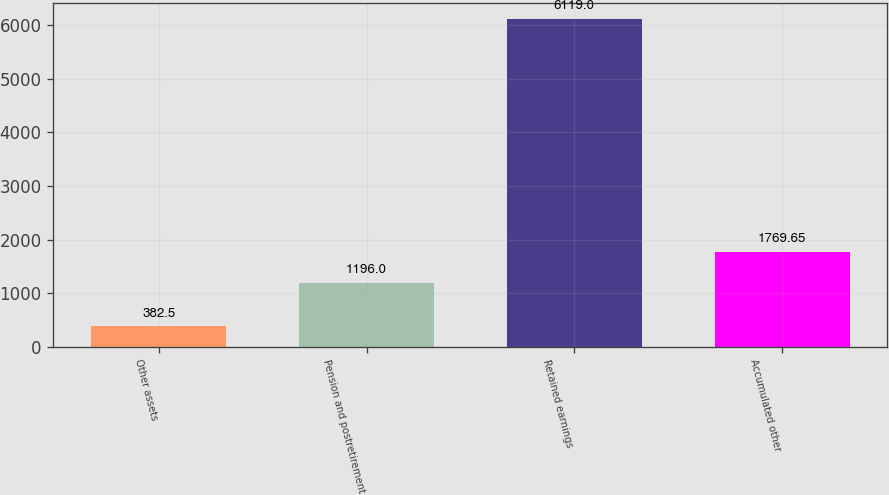Convert chart to OTSL. <chart><loc_0><loc_0><loc_500><loc_500><bar_chart><fcel>Other assets<fcel>Pension and postretirement<fcel>Retained earnings<fcel>Accumulated other<nl><fcel>382.5<fcel>1196<fcel>6119<fcel>1769.65<nl></chart> 